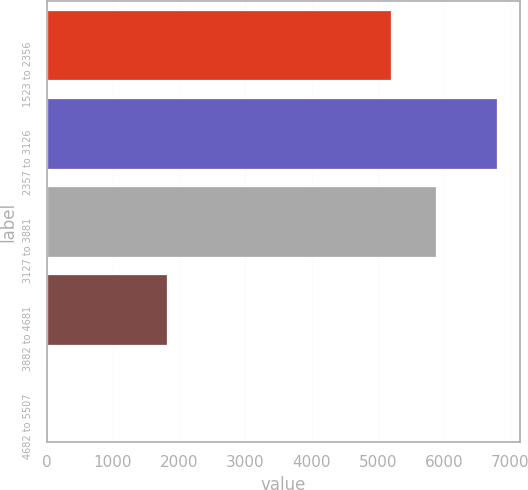<chart> <loc_0><loc_0><loc_500><loc_500><bar_chart><fcel>1523 to 2356<fcel>2357 to 3126<fcel>3127 to 3881<fcel>3882 to 4681<fcel>4682 to 5507<nl><fcel>5194<fcel>6804<fcel>5872.1<fcel>1824<fcel>23<nl></chart> 